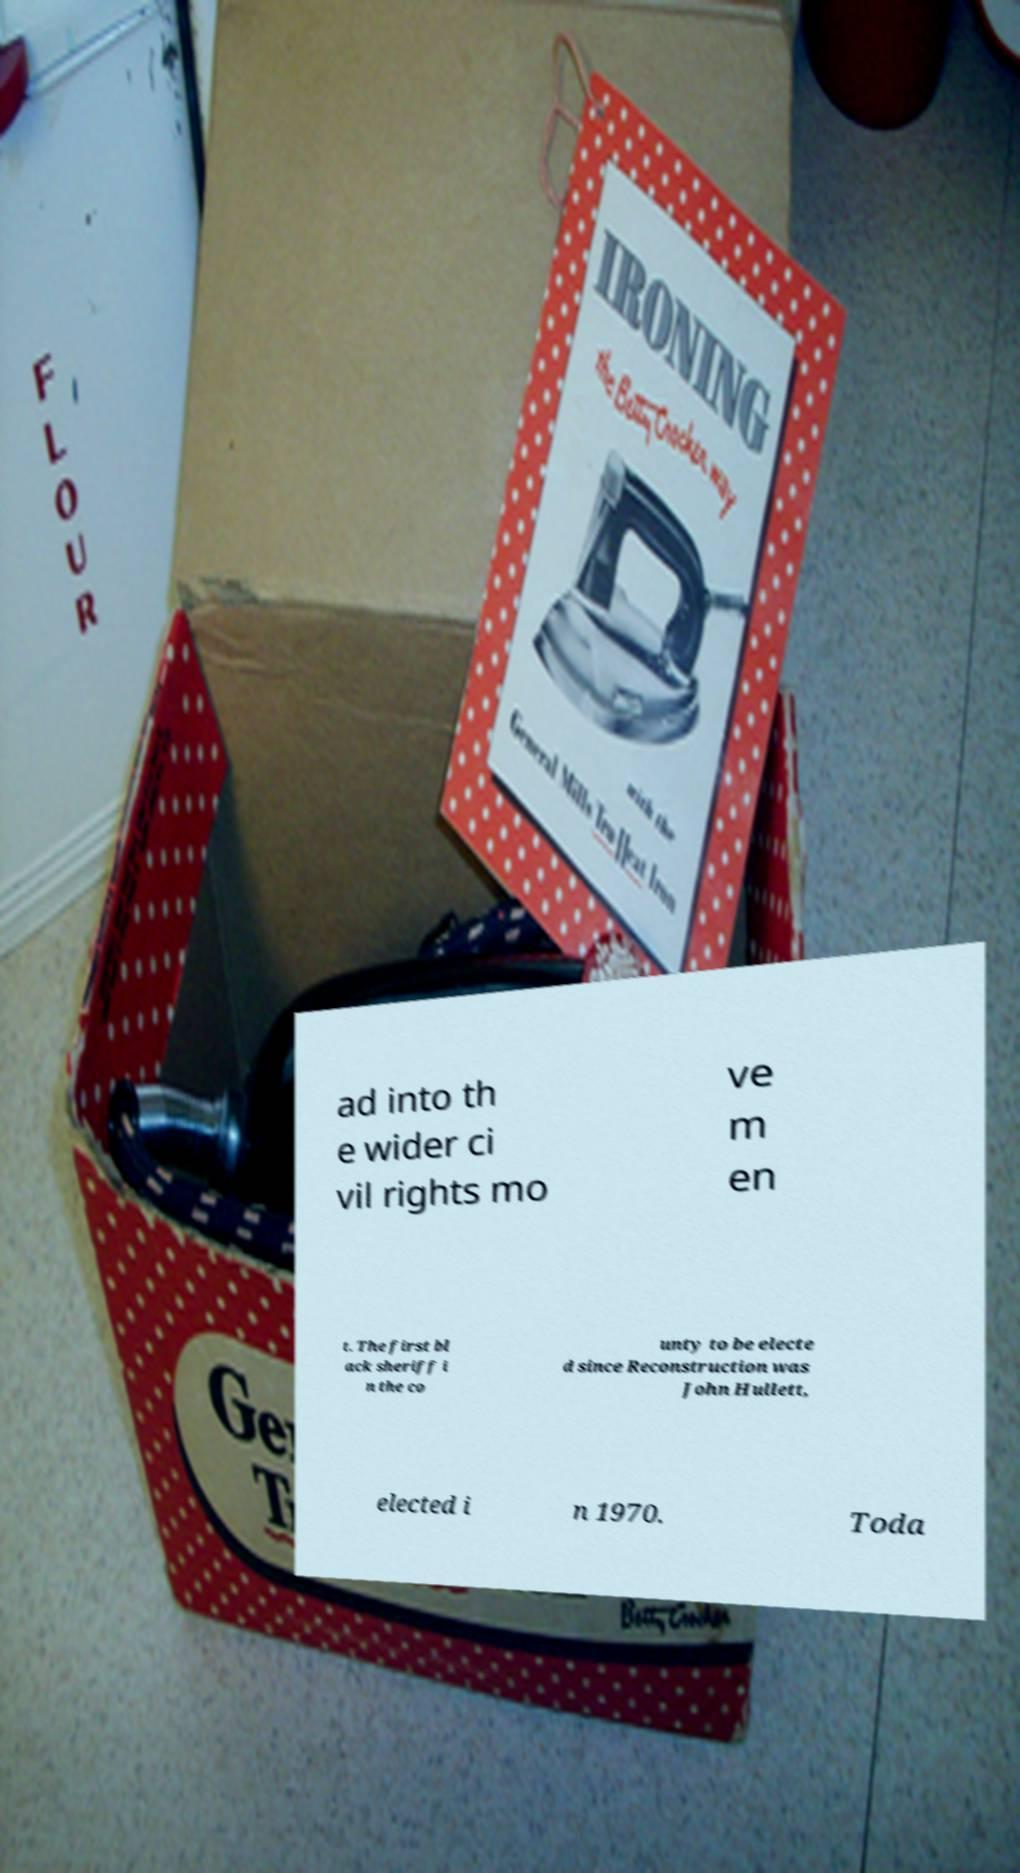Please read and relay the text visible in this image. What does it say? ad into th e wider ci vil rights mo ve m en t. The first bl ack sheriff i n the co unty to be electe d since Reconstruction was John Hullett, elected i n 1970. Toda 